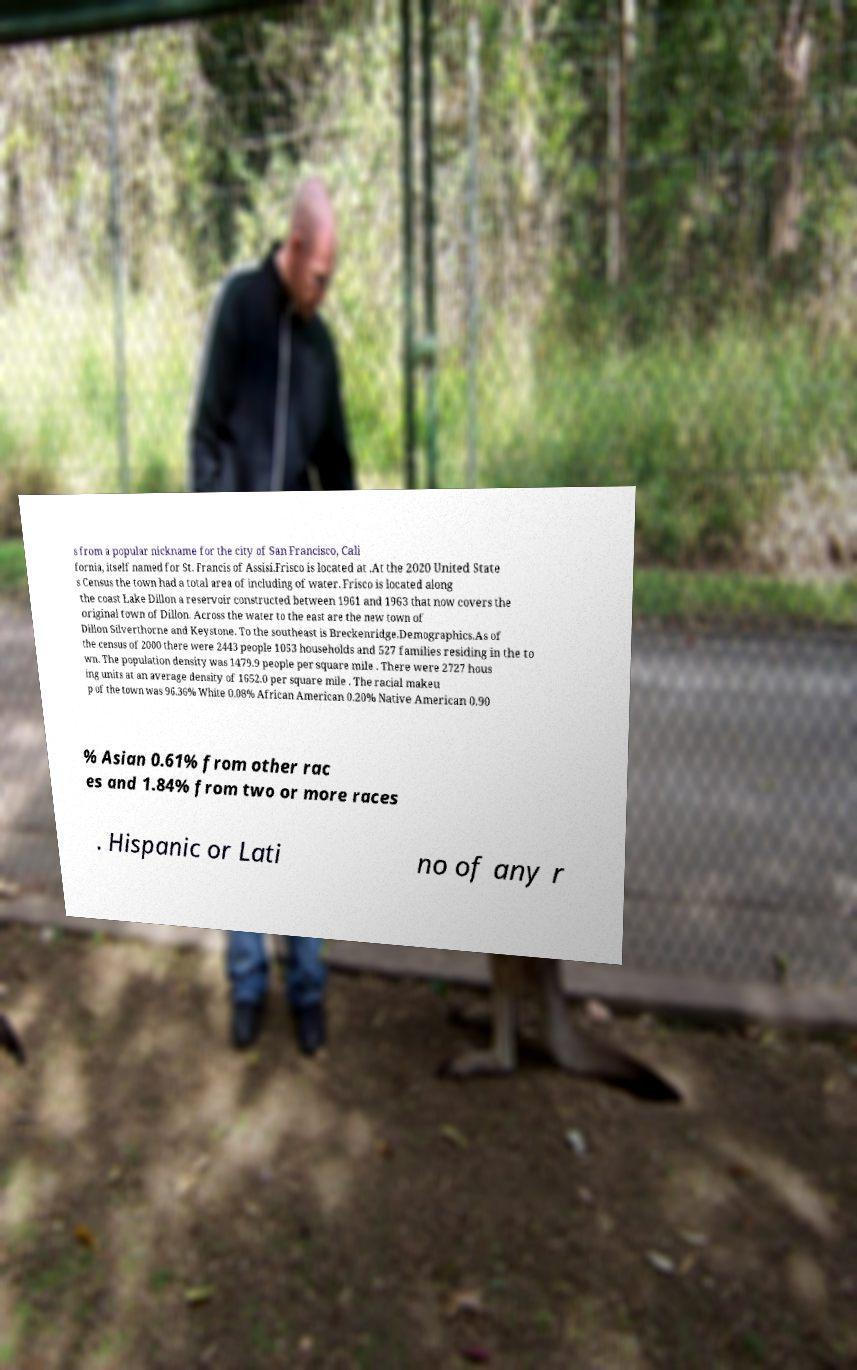Can you accurately transcribe the text from the provided image for me? s from a popular nickname for the city of San Francisco, Cali fornia, itself named for St. Francis of Assisi.Frisco is located at .At the 2020 United State s Census the town had a total area of including of water. Frisco is located along the coast Lake Dillon a reservoir constructed between 1961 and 1963 that now covers the original town of Dillon. Across the water to the east are the new town of Dillon Silverthorne and Keystone. To the southeast is Breckenridge.Demographics.As of the census of 2000 there were 2443 people 1053 households and 527 families residing in the to wn. The population density was 1479.9 people per square mile . There were 2727 hous ing units at an average density of 1652.0 per square mile . The racial makeu p of the town was 96.36% White 0.08% African American 0.20% Native American 0.90 % Asian 0.61% from other rac es and 1.84% from two or more races . Hispanic or Lati no of any r 